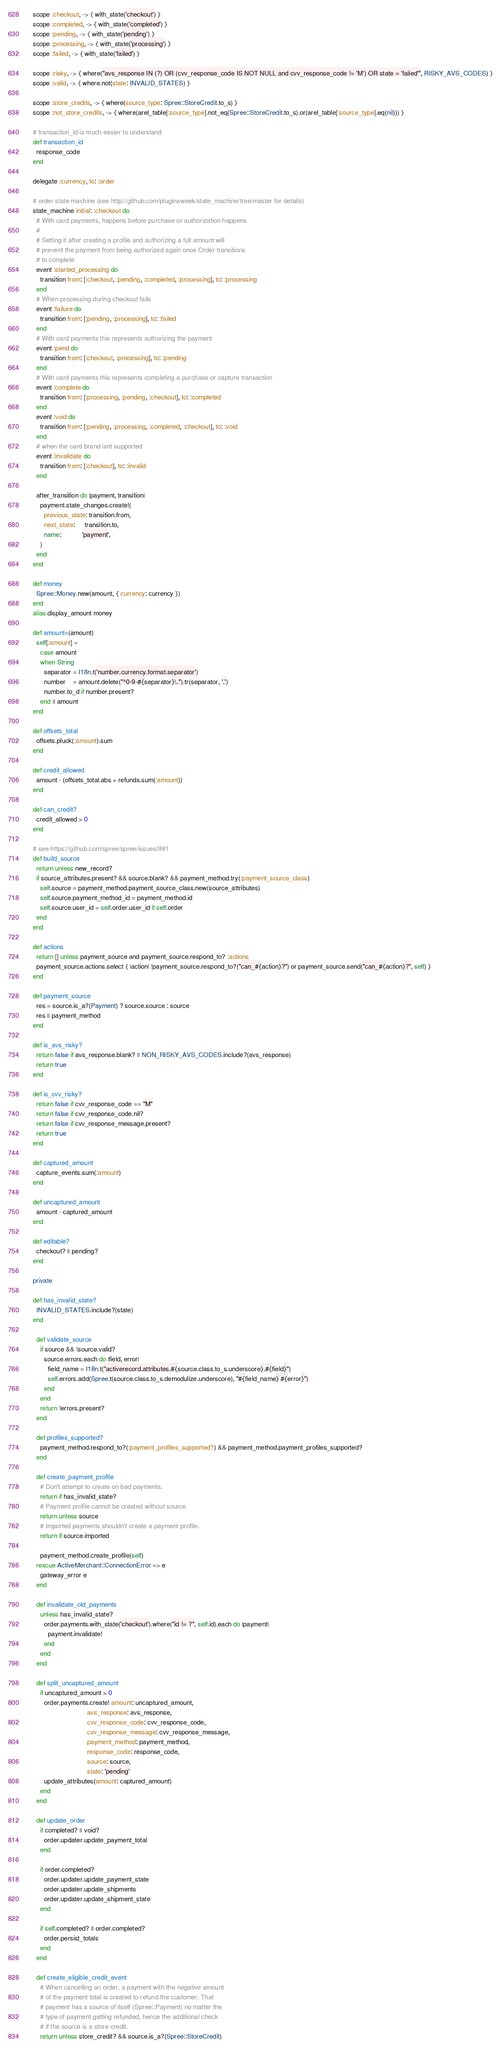<code> <loc_0><loc_0><loc_500><loc_500><_Ruby_>    scope :checkout, -> { with_state('checkout') }
    scope :completed, -> { with_state('completed') }
    scope :pending, -> { with_state('pending') }
    scope :processing, -> { with_state('processing') }
    scope :failed, -> { with_state('failed') }

    scope :risky, -> { where("avs_response IN (?) OR (cvv_response_code IS NOT NULL and cvv_response_code != 'M') OR state = 'failed'", RISKY_AVS_CODES) }
    scope :valid, -> { where.not(state: INVALID_STATES) }

    scope :store_credits, -> { where(source_type: Spree::StoreCredit.to_s) }
    scope :not_store_credits, -> { where(arel_table[:source_type].not_eq(Spree::StoreCredit.to_s).or(arel_table[:source_type].eq(nil))) }

    # transaction_id is much easier to understand
    def transaction_id
      response_code
    end

    delegate :currency, to: :order

    # order state machine (see http://github.com/pluginaweek/state_machine/tree/master for details)
    state_machine initial: :checkout do
      # With card payments, happens before purchase or authorization happens
      #
      # Setting it after creating a profile and authorizing a full amount will
      # prevent the payment from being authorized again once Order transitions
      # to complete
      event :started_processing do
        transition from: [:checkout, :pending, :completed, :processing], to: :processing
      end
      # When processing during checkout fails
      event :failure do
        transition from: [:pending, :processing], to: :failed
      end
      # With card payments this represents authorizing the payment
      event :pend do
        transition from: [:checkout, :processing], to: :pending
      end
      # With card payments this represents completing a purchase or capture transaction
      event :complete do
        transition from: [:processing, :pending, :checkout], to: :completed
      end
      event :void do
        transition from: [:pending, :processing, :completed, :checkout], to: :void
      end
      # when the card brand isnt supported
      event :invalidate do
        transition from: [:checkout], to: :invalid
      end

      after_transition do |payment, transition|
        payment.state_changes.create!(
          previous_state: transition.from,
          next_state:     transition.to,
          name:           'payment',
        )
      end
    end

    def money
      Spree::Money.new(amount, { currency: currency })
    end
    alias display_amount money

    def amount=(amount)
      self[:amount] =
        case amount
        when String
          separator = I18n.t('number.currency.format.separator')
          number    = amount.delete("^0-9-#{separator}\.").tr(separator, '.')
          number.to_d if number.present?
        end || amount
    end

    def offsets_total
      offsets.pluck(:amount).sum
    end

    def credit_allowed
      amount - (offsets_total.abs + refunds.sum(:amount))
    end

    def can_credit?
      credit_allowed > 0
    end

    # see https://github.com/spree/spree/issues/981
    def build_source
      return unless new_record?
      if source_attributes.present? && source.blank? && payment_method.try(:payment_source_class)
        self.source = payment_method.payment_source_class.new(source_attributes)
        self.source.payment_method_id = payment_method.id
        self.source.user_id = self.order.user_id if self.order
      end
    end

    def actions
      return [] unless payment_source and payment_source.respond_to? :actions
      payment_source.actions.select { |action| !payment_source.respond_to?("can_#{action}?") or payment_source.send("can_#{action}?", self) }
    end

    def payment_source
      res = source.is_a?(Payment) ? source.source : source
      res || payment_method
    end

    def is_avs_risky?
      return false if avs_response.blank? || NON_RISKY_AVS_CODES.include?(avs_response)
      return true
    end

    def is_cvv_risky?
      return false if cvv_response_code == "M"
      return false if cvv_response_code.nil?
      return false if cvv_response_message.present?
      return true
    end

    def captured_amount
      capture_events.sum(:amount)
    end

    def uncaptured_amount
      amount - captured_amount
    end

    def editable?
      checkout? || pending?
    end

    private

    def has_invalid_state?
      INVALID_STATES.include?(state)
    end

      def validate_source
        if source && !source.valid?
          source.errors.each do |field, error|
            field_name = I18n.t("activerecord.attributes.#{source.class.to_s.underscore}.#{field}")
            self.errors.add(Spree.t(source.class.to_s.demodulize.underscore), "#{field_name} #{error}")
          end
        end
        return !errors.present?
      end

      def profiles_supported?
        payment_method.respond_to?(:payment_profiles_supported?) && payment_method.payment_profiles_supported?
      end

      def create_payment_profile
        # Don't attempt to create on bad payments.
        return if has_invalid_state?
        # Payment profile cannot be created without source
        return unless source
        # Imported payments shouldn't create a payment profile.
        return if source.imported

        payment_method.create_profile(self)
      rescue ActiveMerchant::ConnectionError => e
        gateway_error e
      end

      def invalidate_old_payments
        unless has_invalid_state?
          order.payments.with_state('checkout').where("id != ?", self.id).each do |payment|
            payment.invalidate!
          end
        end
      end

      def split_uncaptured_amount
        if uncaptured_amount > 0
          order.payments.create! amount: uncaptured_amount,
                                 avs_response: avs_response,
                                 cvv_response_code: cvv_response_code,
                                 cvv_response_message: cvv_response_message,
                                 payment_method: payment_method,
                                 response_code: response_code,
                                 source: source,
                                 state: 'pending'
          update_attributes(amount: captured_amount)
        end
      end

      def update_order
        if completed? || void?
          order.updater.update_payment_total
        end

        if order.completed?
          order.updater.update_payment_state
          order.updater.update_shipments
          order.updater.update_shipment_state
        end

        if self.completed? || order.completed?
          order.persist_totals
        end
      end

      def create_eligible_credit_event
        # When cancelling an order, a payment with the negative amount
        # of the payment total is created to refund the customer. That
        # payment has a source of itself (Spree::Payment) no matter the
        # type of payment getting refunded, hence the additional check
        # if the source is a store credit.
        return unless store_credit? && source.is_a?(Spree::StoreCredit)
</code> 